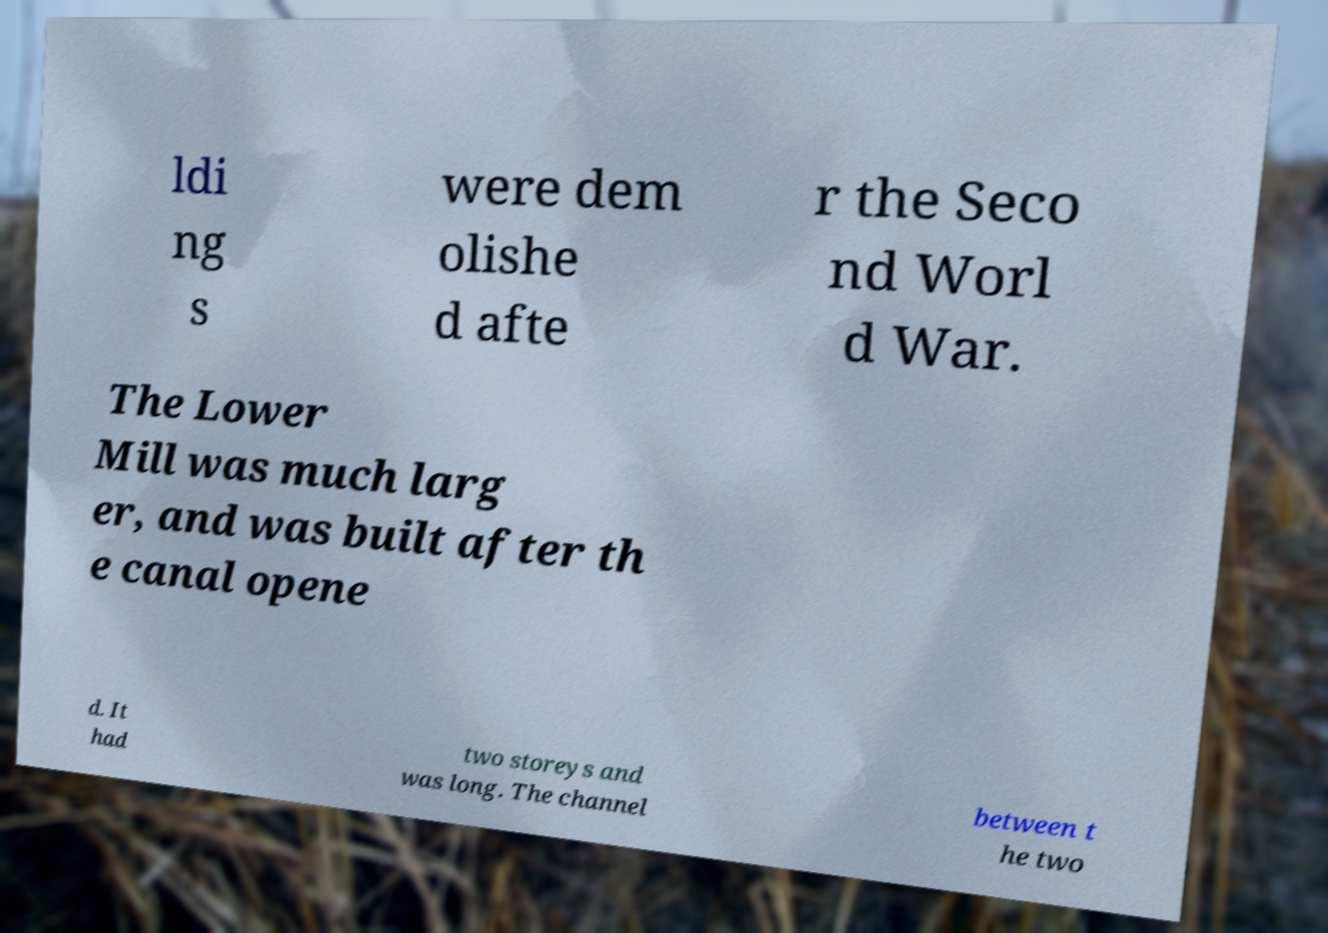For documentation purposes, I need the text within this image transcribed. Could you provide that? ldi ng s were dem olishe d afte r the Seco nd Worl d War. The Lower Mill was much larg er, and was built after th e canal opene d. It had two storeys and was long. The channel between t he two 